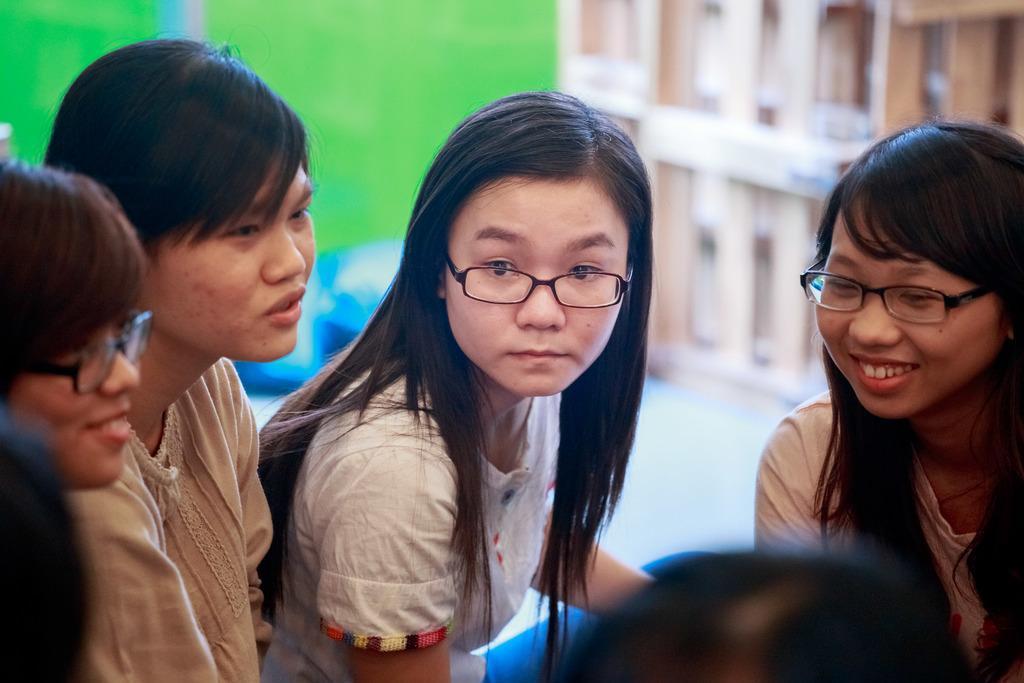Describe this image in one or two sentences. In the image there are a group of girls gathered in the front and the background of them is blur. 